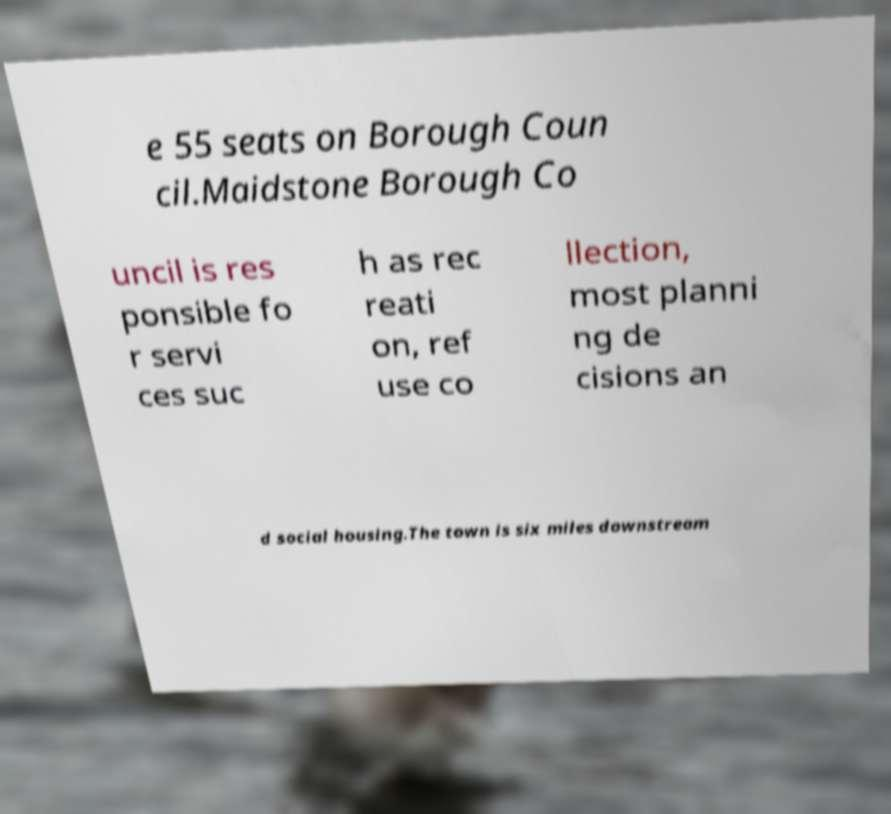Please identify and transcribe the text found in this image. e 55 seats on Borough Coun cil.Maidstone Borough Co uncil is res ponsible fo r servi ces suc h as rec reati on, ref use co llection, most planni ng de cisions an d social housing.The town is six miles downstream 